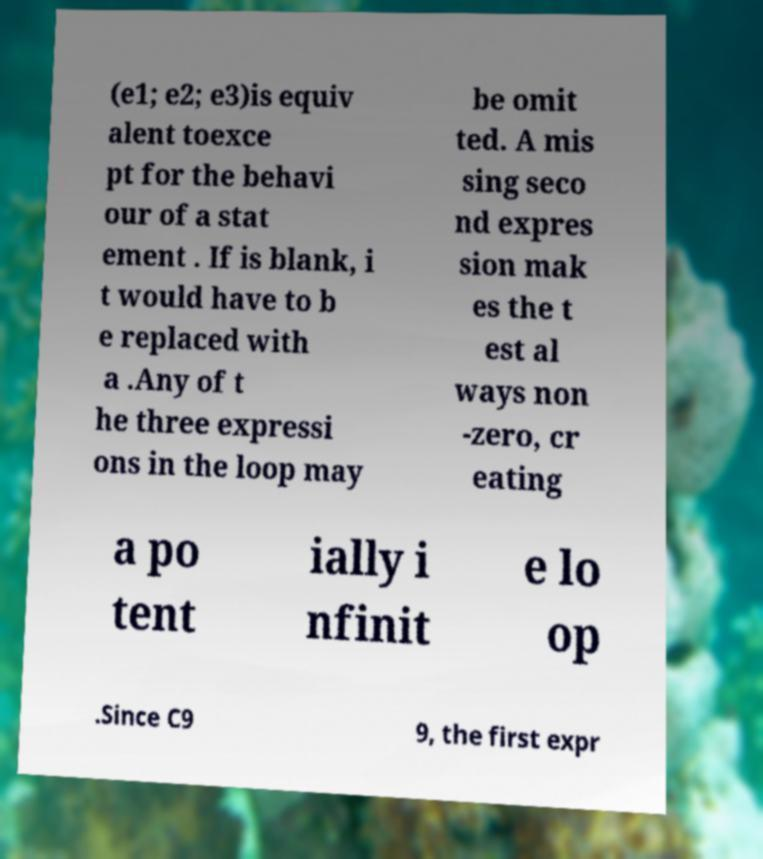Could you assist in decoding the text presented in this image and type it out clearly? (e1; e2; e3)is equiv alent toexce pt for the behavi our of a stat ement . If is blank, i t would have to b e replaced with a .Any of t he three expressi ons in the loop may be omit ted. A mis sing seco nd expres sion mak es the t est al ways non -zero, cr eating a po tent ially i nfinit e lo op .Since C9 9, the first expr 